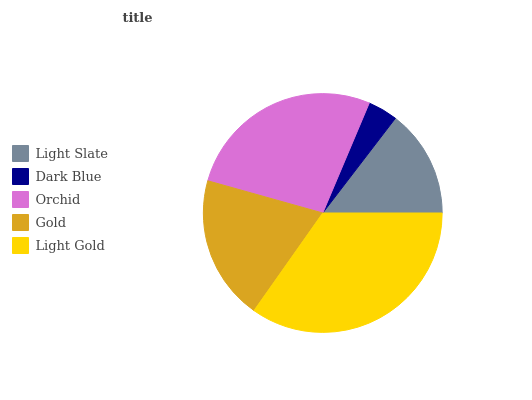Is Dark Blue the minimum?
Answer yes or no. Yes. Is Light Gold the maximum?
Answer yes or no. Yes. Is Orchid the minimum?
Answer yes or no. No. Is Orchid the maximum?
Answer yes or no. No. Is Orchid greater than Dark Blue?
Answer yes or no. Yes. Is Dark Blue less than Orchid?
Answer yes or no. Yes. Is Dark Blue greater than Orchid?
Answer yes or no. No. Is Orchid less than Dark Blue?
Answer yes or no. No. Is Gold the high median?
Answer yes or no. Yes. Is Gold the low median?
Answer yes or no. Yes. Is Light Gold the high median?
Answer yes or no. No. Is Light Gold the low median?
Answer yes or no. No. 